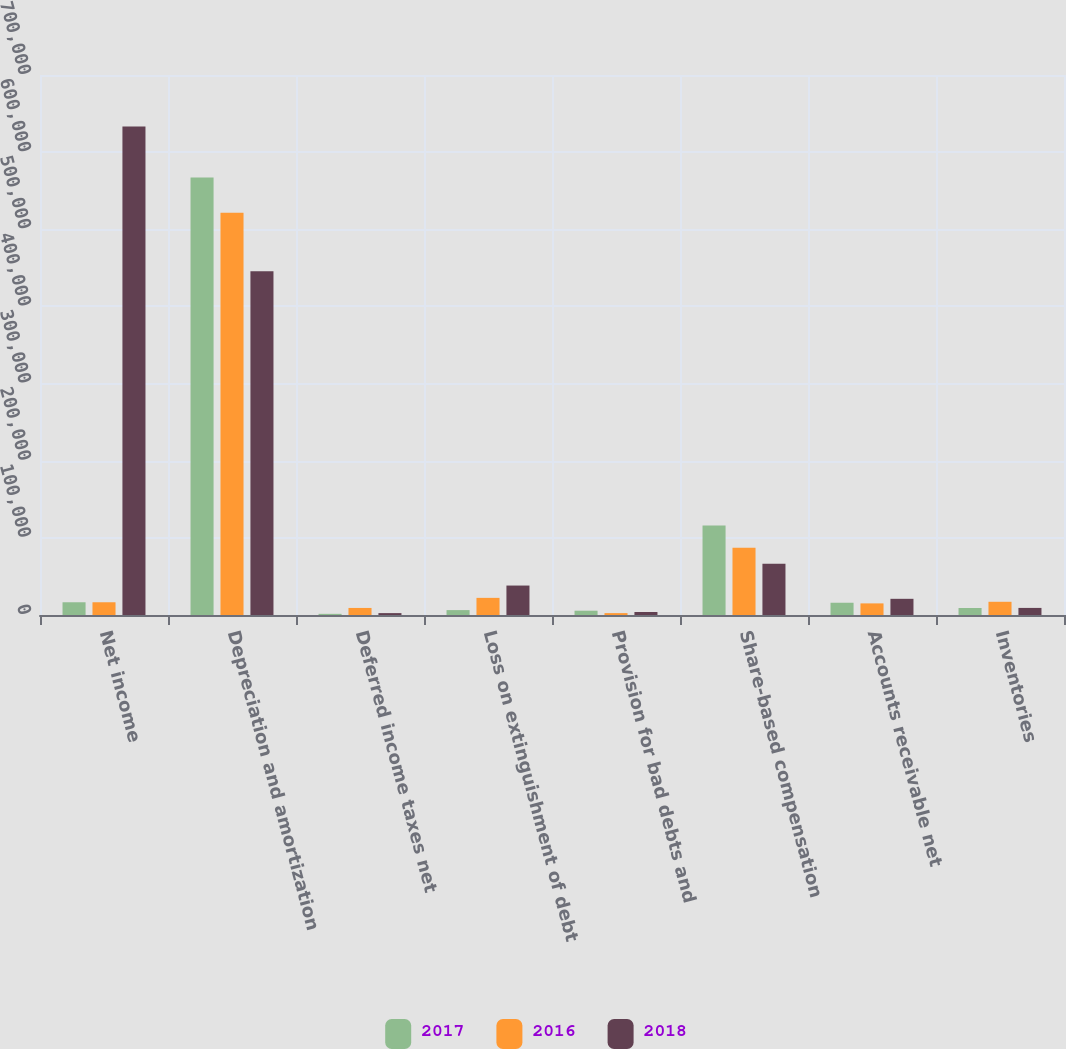Convert chart to OTSL. <chart><loc_0><loc_0><loc_500><loc_500><stacked_bar_chart><ecel><fcel>Net income<fcel>Depreciation and amortization<fcel>Deferred income taxes net<fcel>Loss on extinguishment of debt<fcel>Provision for bad debts and<fcel>Share-based compensation<fcel>Accounts receivable net<fcel>Inventories<nl><fcel>2017<fcel>16507.5<fcel>566972<fcel>1508<fcel>6346<fcel>5570<fcel>115983<fcel>15886<fcel>9052<nl><fcel>2016<fcel>16507.5<fcel>521484<fcel>9153<fcel>22211<fcel>2431<fcel>87039<fcel>15050<fcel>17129<nl><fcel>2018<fcel>633085<fcel>445635<fcel>2448<fcel>38180<fcel>3866<fcel>66414<fcel>20983<fcel>9184<nl></chart> 